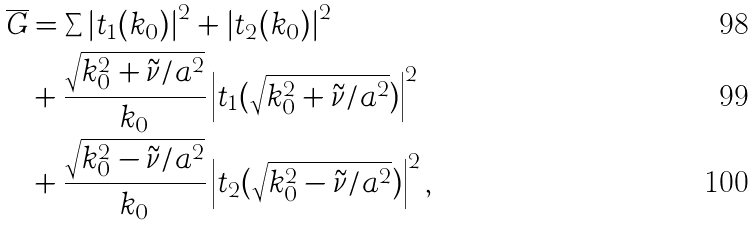<formula> <loc_0><loc_0><loc_500><loc_500>\overline { G } & = \sum \left | t _ { 1 } ( k _ { 0 } ) \right | ^ { 2 } + \left | t _ { 2 } ( k _ { 0 } ) \right | ^ { 2 } \\ & + \frac { \sqrt { k _ { 0 } ^ { 2 } + \tilde { \nu } / a ^ { 2 } } } { k _ { 0 } } \left | t _ { 1 } ( \sqrt { k _ { 0 } ^ { 2 } + \tilde { \nu } / a ^ { 2 } } ) \right | ^ { 2 } \\ & + \frac { \sqrt { k _ { 0 } ^ { 2 } - \tilde { \nu } / a ^ { 2 } } } { k _ { 0 } } \left | t _ { 2 } ( \sqrt { k _ { 0 } ^ { 2 } - \tilde { \nu } / a ^ { 2 } } ) \right | ^ { 2 } ,</formula> 